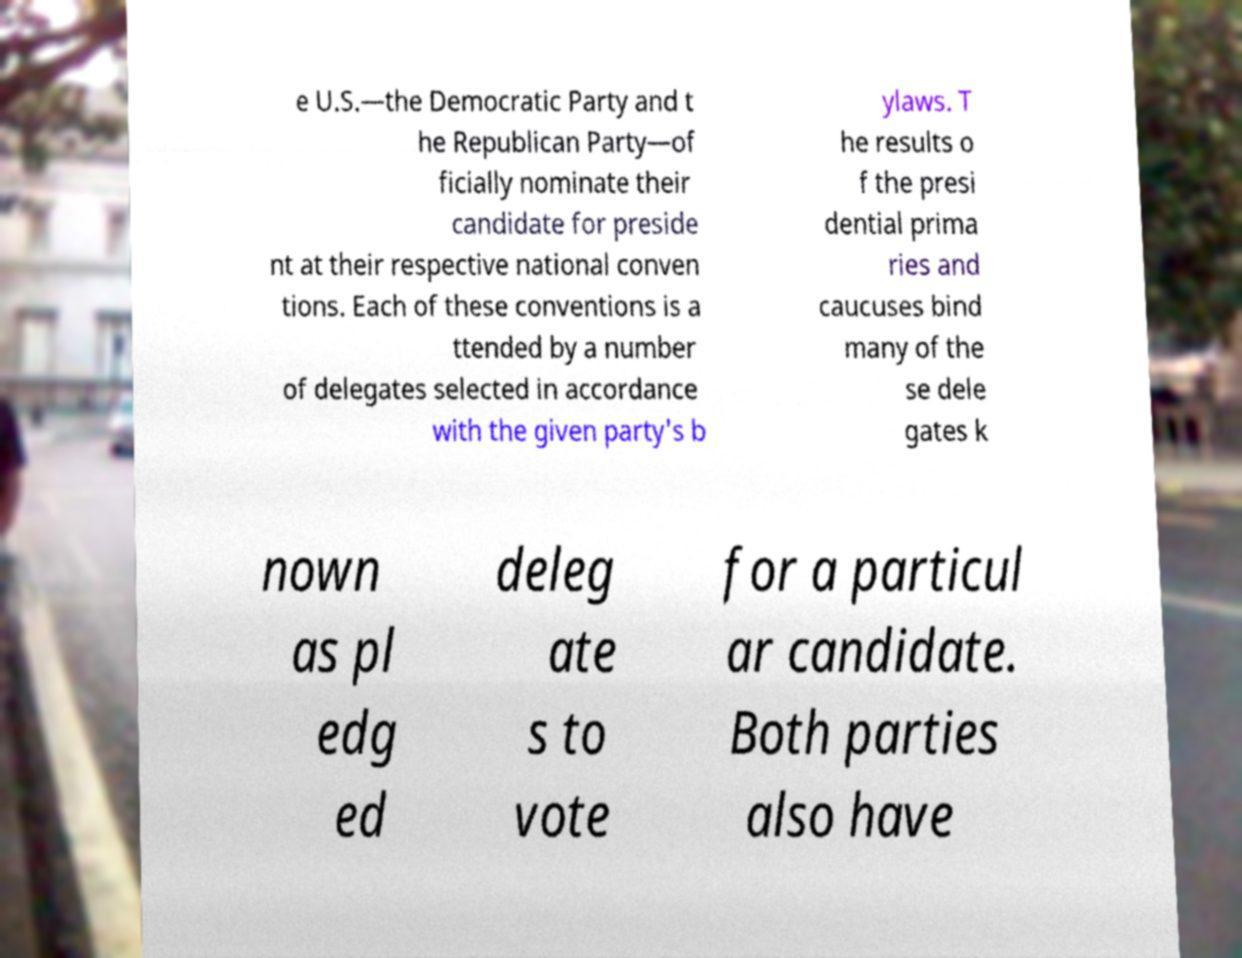Please identify and transcribe the text found in this image. e U.S.—the Democratic Party and t he Republican Party—of ficially nominate their candidate for preside nt at their respective national conven tions. Each of these conventions is a ttended by a number of delegates selected in accordance with the given party's b ylaws. T he results o f the presi dential prima ries and caucuses bind many of the se dele gates k nown as pl edg ed deleg ate s to vote for a particul ar candidate. Both parties also have 